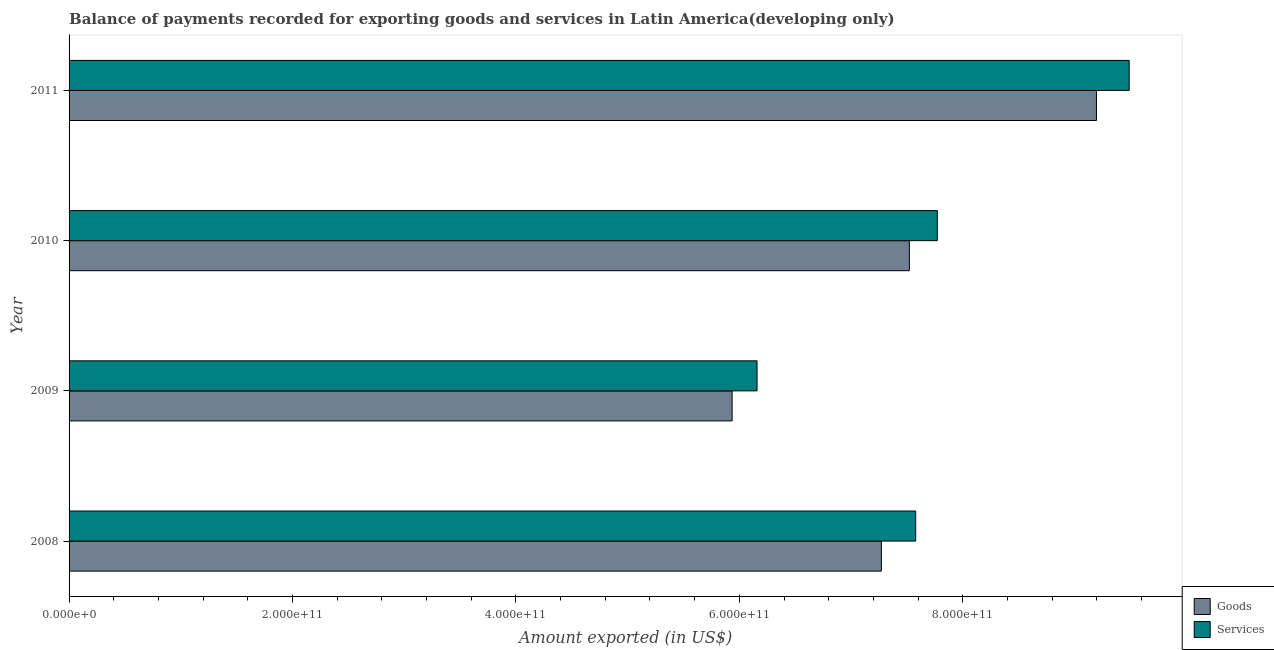How many different coloured bars are there?
Your answer should be very brief. 2. How many groups of bars are there?
Keep it short and to the point. 4. Are the number of bars per tick equal to the number of legend labels?
Give a very brief answer. Yes. In how many cases, is the number of bars for a given year not equal to the number of legend labels?
Your answer should be compact. 0. What is the amount of goods exported in 2010?
Provide a succinct answer. 7.52e+11. Across all years, what is the maximum amount of services exported?
Provide a short and direct response. 9.49e+11. Across all years, what is the minimum amount of goods exported?
Keep it short and to the point. 5.94e+11. What is the total amount of services exported in the graph?
Your answer should be very brief. 3.10e+12. What is the difference between the amount of services exported in 2008 and that in 2009?
Give a very brief answer. 1.42e+11. What is the difference between the amount of goods exported in 2008 and the amount of services exported in 2010?
Your answer should be very brief. -5.01e+1. What is the average amount of services exported per year?
Ensure brevity in your answer.  7.75e+11. In the year 2011, what is the difference between the amount of goods exported and amount of services exported?
Provide a succinct answer. -2.93e+1. What is the ratio of the amount of services exported in 2008 to that in 2009?
Make the answer very short. 1.23. Is the amount of services exported in 2009 less than that in 2010?
Your answer should be compact. Yes. Is the difference between the amount of goods exported in 2008 and 2009 greater than the difference between the amount of services exported in 2008 and 2009?
Offer a terse response. No. What is the difference between the highest and the second highest amount of goods exported?
Provide a short and direct response. 1.67e+11. What is the difference between the highest and the lowest amount of services exported?
Offer a very short reply. 3.33e+11. Is the sum of the amount of services exported in 2008 and 2009 greater than the maximum amount of goods exported across all years?
Offer a very short reply. Yes. What does the 2nd bar from the top in 2010 represents?
Offer a terse response. Goods. What does the 2nd bar from the bottom in 2009 represents?
Offer a very short reply. Services. What is the difference between two consecutive major ticks on the X-axis?
Offer a terse response. 2.00e+11. Does the graph contain any zero values?
Provide a succinct answer. No. Where does the legend appear in the graph?
Provide a succinct answer. Bottom right. How many legend labels are there?
Keep it short and to the point. 2. What is the title of the graph?
Ensure brevity in your answer.  Balance of payments recorded for exporting goods and services in Latin America(developing only). Does "From human activities" appear as one of the legend labels in the graph?
Offer a very short reply. No. What is the label or title of the X-axis?
Provide a succinct answer. Amount exported (in US$). What is the label or title of the Y-axis?
Provide a short and direct response. Year. What is the Amount exported (in US$) in Goods in 2008?
Provide a short and direct response. 7.27e+11. What is the Amount exported (in US$) in Services in 2008?
Give a very brief answer. 7.58e+11. What is the Amount exported (in US$) in Goods in 2009?
Offer a very short reply. 5.94e+11. What is the Amount exported (in US$) in Services in 2009?
Offer a terse response. 6.16e+11. What is the Amount exported (in US$) of Goods in 2010?
Offer a terse response. 7.52e+11. What is the Amount exported (in US$) in Services in 2010?
Offer a very short reply. 7.77e+11. What is the Amount exported (in US$) of Goods in 2011?
Ensure brevity in your answer.  9.20e+11. What is the Amount exported (in US$) in Services in 2011?
Offer a terse response. 9.49e+11. Across all years, what is the maximum Amount exported (in US$) in Goods?
Provide a short and direct response. 9.20e+11. Across all years, what is the maximum Amount exported (in US$) of Services?
Offer a terse response. 9.49e+11. Across all years, what is the minimum Amount exported (in US$) in Goods?
Your response must be concise. 5.94e+11. Across all years, what is the minimum Amount exported (in US$) of Services?
Keep it short and to the point. 6.16e+11. What is the total Amount exported (in US$) in Goods in the graph?
Make the answer very short. 2.99e+12. What is the total Amount exported (in US$) in Services in the graph?
Your answer should be very brief. 3.10e+12. What is the difference between the Amount exported (in US$) of Goods in 2008 and that in 2009?
Your response must be concise. 1.34e+11. What is the difference between the Amount exported (in US$) in Services in 2008 and that in 2009?
Keep it short and to the point. 1.42e+11. What is the difference between the Amount exported (in US$) in Goods in 2008 and that in 2010?
Keep it short and to the point. -2.50e+1. What is the difference between the Amount exported (in US$) in Services in 2008 and that in 2010?
Make the answer very short. -1.94e+1. What is the difference between the Amount exported (in US$) of Goods in 2008 and that in 2011?
Keep it short and to the point. -1.93e+11. What is the difference between the Amount exported (in US$) of Services in 2008 and that in 2011?
Provide a succinct answer. -1.91e+11. What is the difference between the Amount exported (in US$) of Goods in 2009 and that in 2010?
Keep it short and to the point. -1.59e+11. What is the difference between the Amount exported (in US$) in Services in 2009 and that in 2010?
Your answer should be very brief. -1.61e+11. What is the difference between the Amount exported (in US$) of Goods in 2009 and that in 2011?
Offer a terse response. -3.26e+11. What is the difference between the Amount exported (in US$) of Services in 2009 and that in 2011?
Make the answer very short. -3.33e+11. What is the difference between the Amount exported (in US$) of Goods in 2010 and that in 2011?
Provide a succinct answer. -1.67e+11. What is the difference between the Amount exported (in US$) of Services in 2010 and that in 2011?
Ensure brevity in your answer.  -1.72e+11. What is the difference between the Amount exported (in US$) in Goods in 2008 and the Amount exported (in US$) in Services in 2009?
Offer a terse response. 1.11e+11. What is the difference between the Amount exported (in US$) in Goods in 2008 and the Amount exported (in US$) in Services in 2010?
Make the answer very short. -5.01e+1. What is the difference between the Amount exported (in US$) in Goods in 2008 and the Amount exported (in US$) in Services in 2011?
Ensure brevity in your answer.  -2.22e+11. What is the difference between the Amount exported (in US$) in Goods in 2009 and the Amount exported (in US$) in Services in 2010?
Provide a succinct answer. -1.84e+11. What is the difference between the Amount exported (in US$) in Goods in 2009 and the Amount exported (in US$) in Services in 2011?
Keep it short and to the point. -3.55e+11. What is the difference between the Amount exported (in US$) in Goods in 2010 and the Amount exported (in US$) in Services in 2011?
Make the answer very short. -1.97e+11. What is the average Amount exported (in US$) of Goods per year?
Your answer should be very brief. 7.48e+11. What is the average Amount exported (in US$) in Services per year?
Provide a succinct answer. 7.75e+11. In the year 2008, what is the difference between the Amount exported (in US$) in Goods and Amount exported (in US$) in Services?
Your answer should be very brief. -3.07e+1. In the year 2009, what is the difference between the Amount exported (in US$) of Goods and Amount exported (in US$) of Services?
Keep it short and to the point. -2.23e+1. In the year 2010, what is the difference between the Amount exported (in US$) of Goods and Amount exported (in US$) of Services?
Your response must be concise. -2.51e+1. In the year 2011, what is the difference between the Amount exported (in US$) of Goods and Amount exported (in US$) of Services?
Offer a very short reply. -2.93e+1. What is the ratio of the Amount exported (in US$) in Goods in 2008 to that in 2009?
Provide a short and direct response. 1.23. What is the ratio of the Amount exported (in US$) in Services in 2008 to that in 2009?
Your answer should be compact. 1.23. What is the ratio of the Amount exported (in US$) in Goods in 2008 to that in 2010?
Make the answer very short. 0.97. What is the ratio of the Amount exported (in US$) of Goods in 2008 to that in 2011?
Offer a very short reply. 0.79. What is the ratio of the Amount exported (in US$) of Services in 2008 to that in 2011?
Your answer should be very brief. 0.8. What is the ratio of the Amount exported (in US$) in Goods in 2009 to that in 2010?
Your answer should be very brief. 0.79. What is the ratio of the Amount exported (in US$) of Services in 2009 to that in 2010?
Provide a short and direct response. 0.79. What is the ratio of the Amount exported (in US$) of Goods in 2009 to that in 2011?
Your response must be concise. 0.65. What is the ratio of the Amount exported (in US$) of Services in 2009 to that in 2011?
Your answer should be very brief. 0.65. What is the ratio of the Amount exported (in US$) in Goods in 2010 to that in 2011?
Offer a very short reply. 0.82. What is the ratio of the Amount exported (in US$) in Services in 2010 to that in 2011?
Make the answer very short. 0.82. What is the difference between the highest and the second highest Amount exported (in US$) of Goods?
Ensure brevity in your answer.  1.67e+11. What is the difference between the highest and the second highest Amount exported (in US$) in Services?
Offer a very short reply. 1.72e+11. What is the difference between the highest and the lowest Amount exported (in US$) in Goods?
Your answer should be very brief. 3.26e+11. What is the difference between the highest and the lowest Amount exported (in US$) in Services?
Offer a terse response. 3.33e+11. 